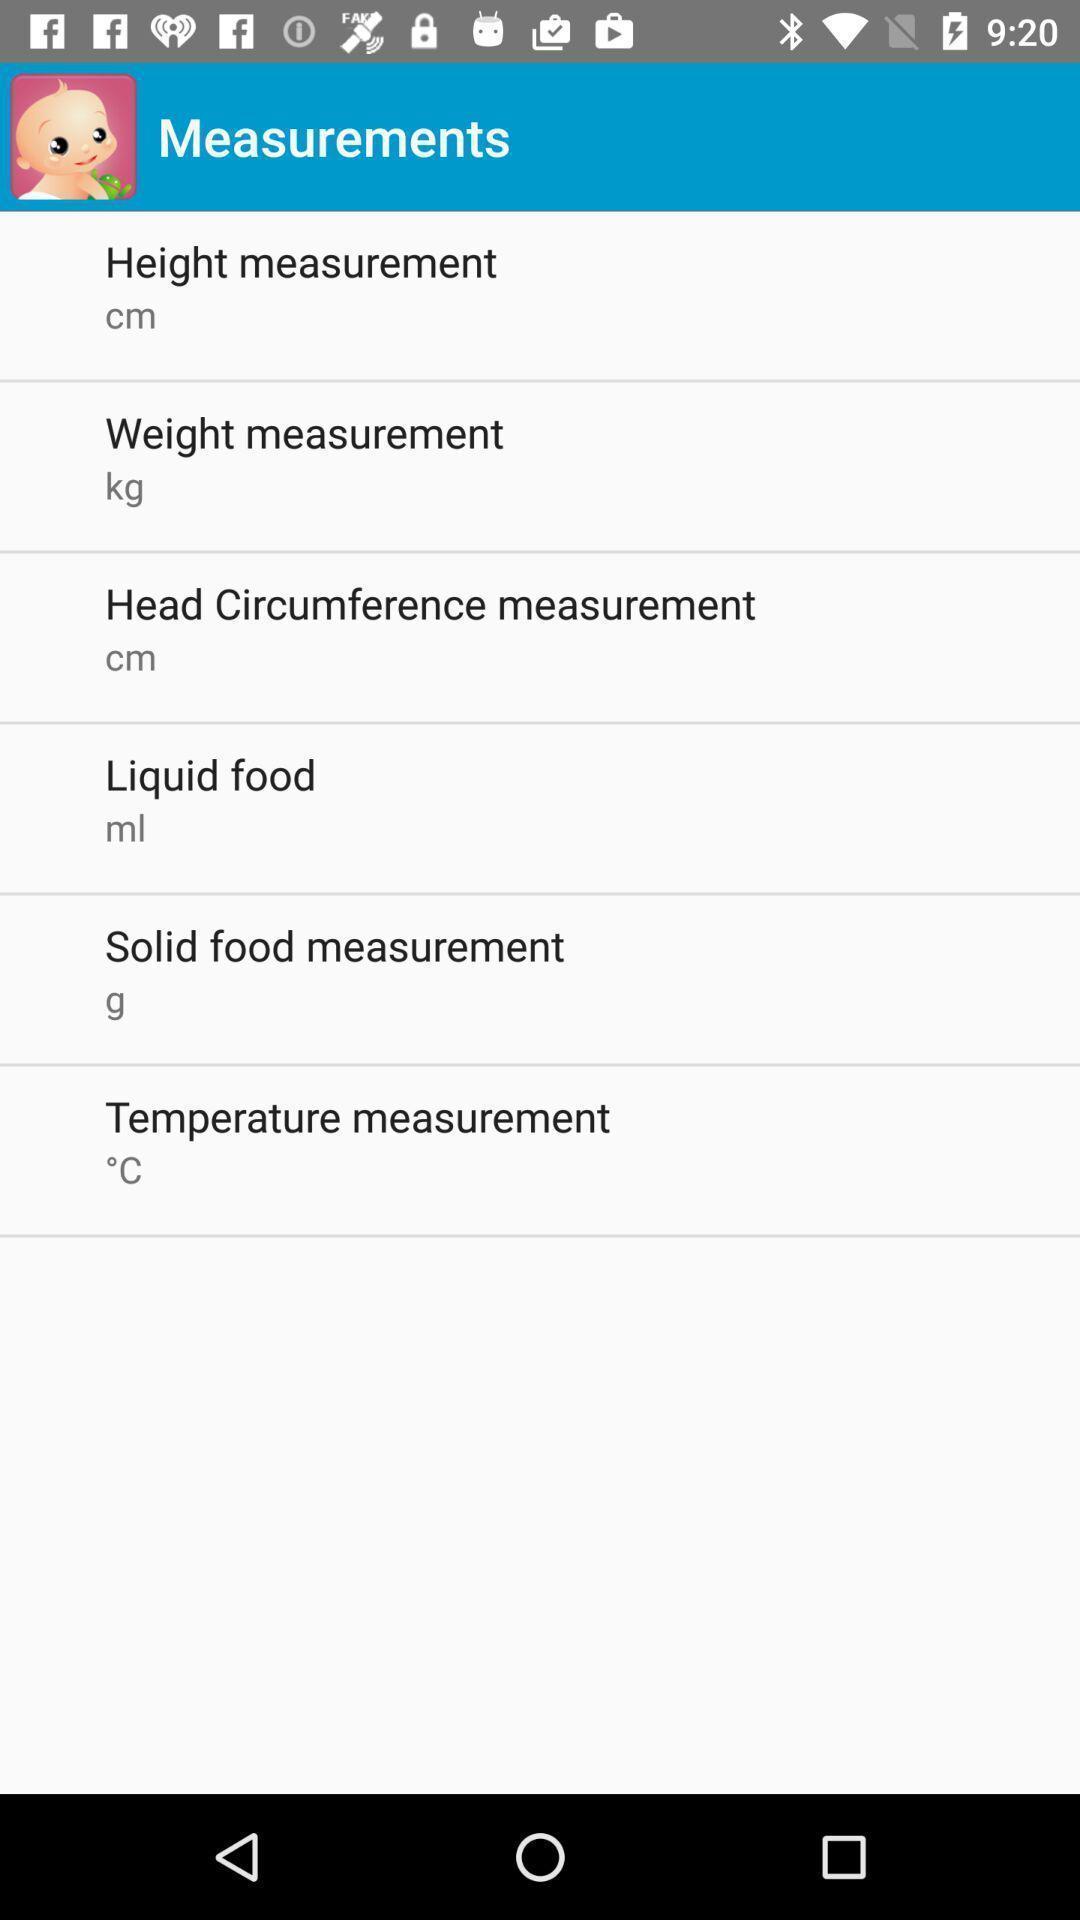Give me a narrative description of this picture. Page for baby health tracking app. 